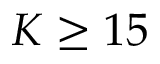<formula> <loc_0><loc_0><loc_500><loc_500>K \geq 1 5</formula> 